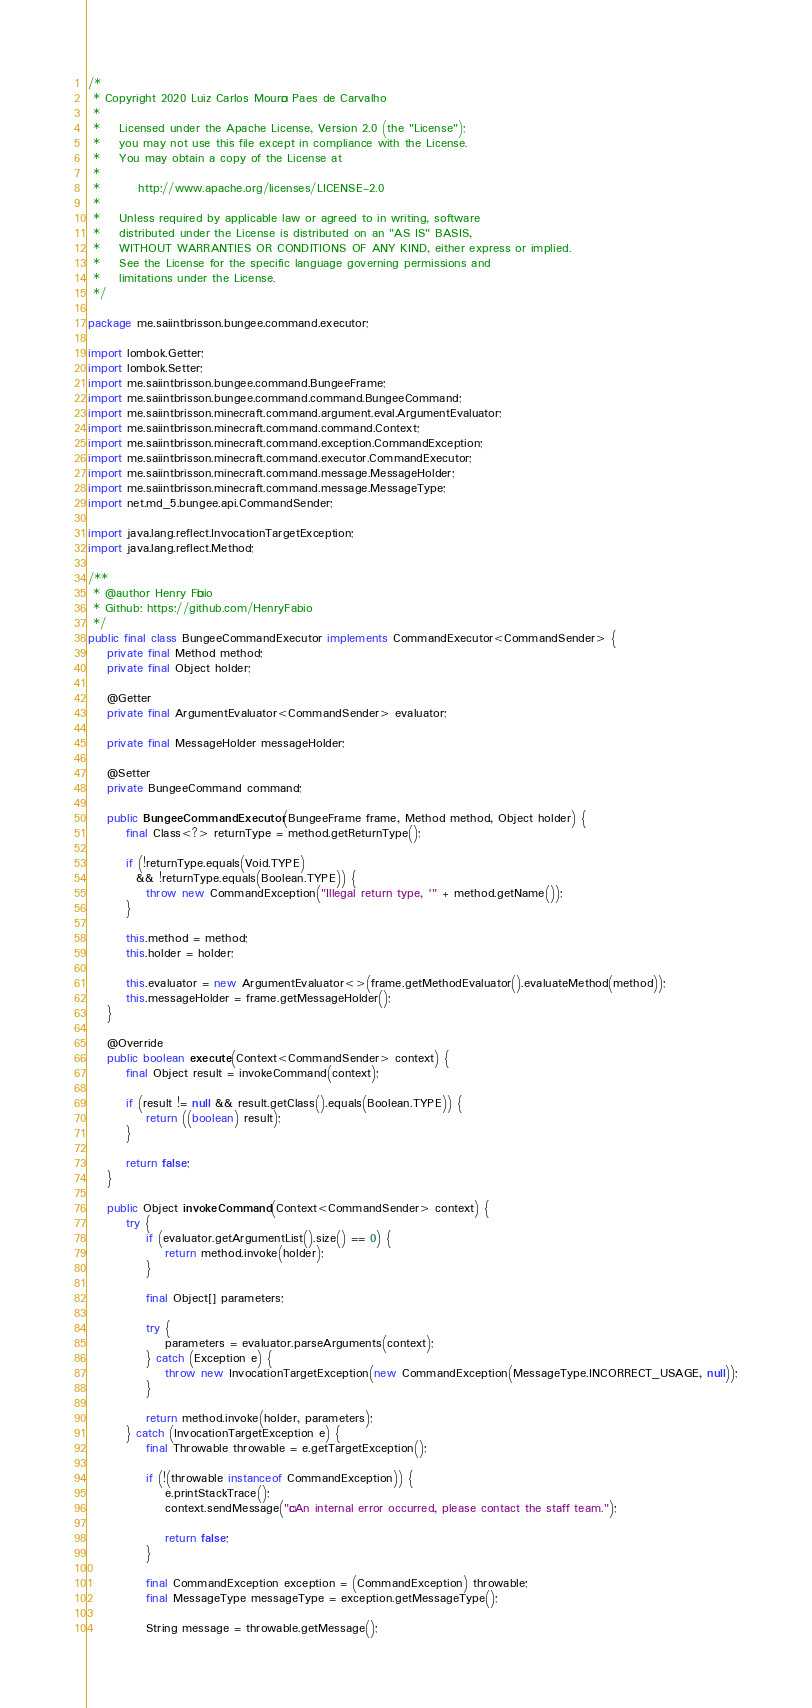<code> <loc_0><loc_0><loc_500><loc_500><_Java_>/*
 * Copyright 2020 Luiz Carlos Mourão Paes de Carvalho
 *
 *    Licensed under the Apache License, Version 2.0 (the "License");
 *    you may not use this file except in compliance with the License.
 *    You may obtain a copy of the License at
 *
 *        http://www.apache.org/licenses/LICENSE-2.0
 *
 *    Unless required by applicable law or agreed to in writing, software
 *    distributed under the License is distributed on an "AS IS" BASIS,
 *    WITHOUT WARRANTIES OR CONDITIONS OF ANY KIND, either express or implied.
 *    See the License for the specific language governing permissions and
 *    limitations under the License.
 */

package me.saiintbrisson.bungee.command.executor;

import lombok.Getter;
import lombok.Setter;
import me.saiintbrisson.bungee.command.BungeeFrame;
import me.saiintbrisson.bungee.command.command.BungeeCommand;
import me.saiintbrisson.minecraft.command.argument.eval.ArgumentEvaluator;
import me.saiintbrisson.minecraft.command.command.Context;
import me.saiintbrisson.minecraft.command.exception.CommandException;
import me.saiintbrisson.minecraft.command.executor.CommandExecutor;
import me.saiintbrisson.minecraft.command.message.MessageHolder;
import me.saiintbrisson.minecraft.command.message.MessageType;
import net.md_5.bungee.api.CommandSender;

import java.lang.reflect.InvocationTargetException;
import java.lang.reflect.Method;

/**
 * @author Henry Fábio
 * Github: https://github.com/HenryFabio
 */
public final class BungeeCommandExecutor implements CommandExecutor<CommandSender> {
    private final Method method;
    private final Object holder;

    @Getter
    private final ArgumentEvaluator<CommandSender> evaluator;

    private final MessageHolder messageHolder;

    @Setter
    private BungeeCommand command;

    public BungeeCommandExecutor(BungeeFrame frame, Method method, Object holder) {
        final Class<?> returnType = method.getReturnType();

        if (!returnType.equals(Void.TYPE)
          && !returnType.equals(Boolean.TYPE)) {
            throw new CommandException("Illegal return type, '" + method.getName());
        }

        this.method = method;
        this.holder = holder;

        this.evaluator = new ArgumentEvaluator<>(frame.getMethodEvaluator().evaluateMethod(method));
        this.messageHolder = frame.getMessageHolder();
    }

    @Override
    public boolean execute(Context<CommandSender> context) {
        final Object result = invokeCommand(context);

        if (result != null && result.getClass().equals(Boolean.TYPE)) {
            return ((boolean) result);
        }

        return false;
    }

    public Object invokeCommand(Context<CommandSender> context) {
        try {
            if (evaluator.getArgumentList().size() == 0) {
                return method.invoke(holder);
            }

            final Object[] parameters;

            try {
                parameters = evaluator.parseArguments(context);
            } catch (Exception e) {
                throw new InvocationTargetException(new CommandException(MessageType.INCORRECT_USAGE, null));
            }

            return method.invoke(holder, parameters);
        } catch (InvocationTargetException e) {
            final Throwable throwable = e.getTargetException();

            if (!(throwable instanceof CommandException)) {
                e.printStackTrace();
                context.sendMessage("§cAn internal error occurred, please contact the staff team.");

                return false;
            }

            final CommandException exception = (CommandException) throwable;
            final MessageType messageType = exception.getMessageType();

            String message = throwable.getMessage();
</code> 